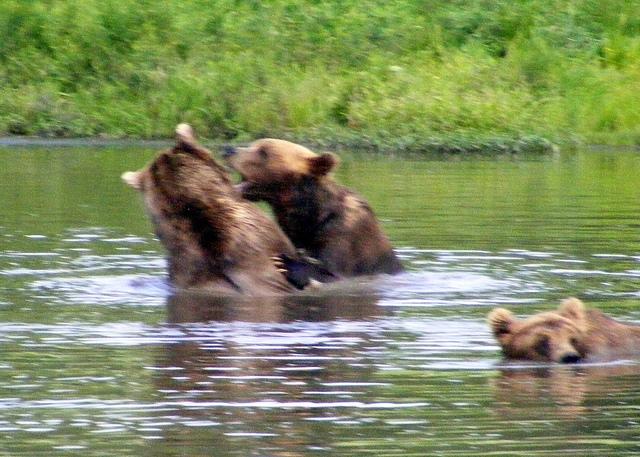How far does the water come up on the bears?
Give a very brief answer. Chest. How many bears are shown?
Quick response, please. 3. Can you see more than 2 bears?
Short answer required. Yes. 